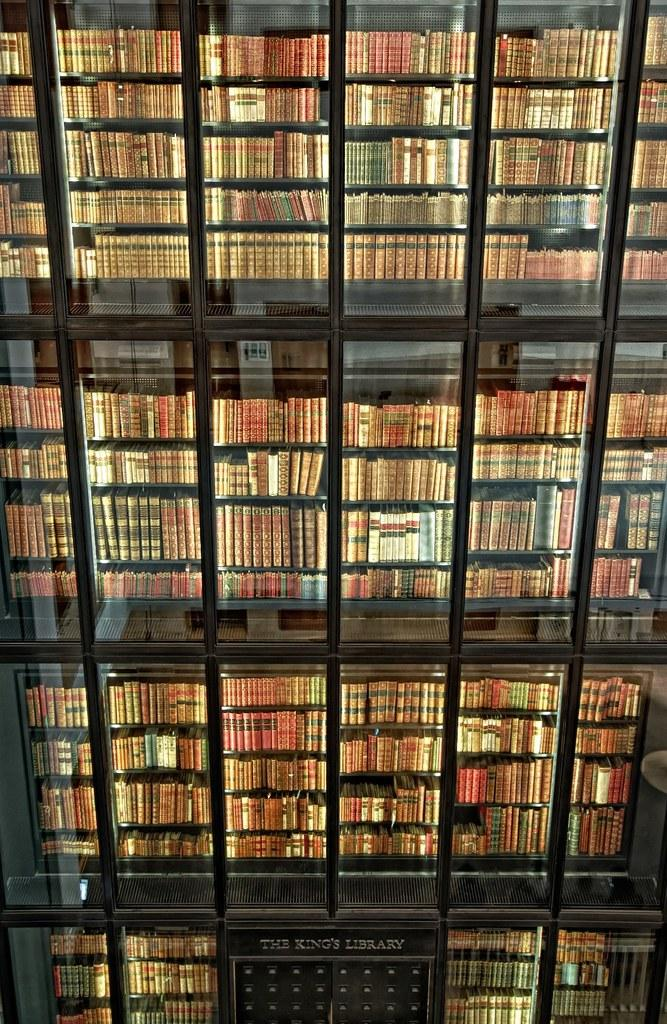What objects are present in the image? There are books in the image. How are the books arranged in the image? The books are in racks. What can be observed about the appearance of the books? The books have different colors. What type of farmer is depicted in the image? There is no farmer present in the image; it features books in racks. What is the condition of the jail in the image? There is no jail present in the image; it features books in racks. 